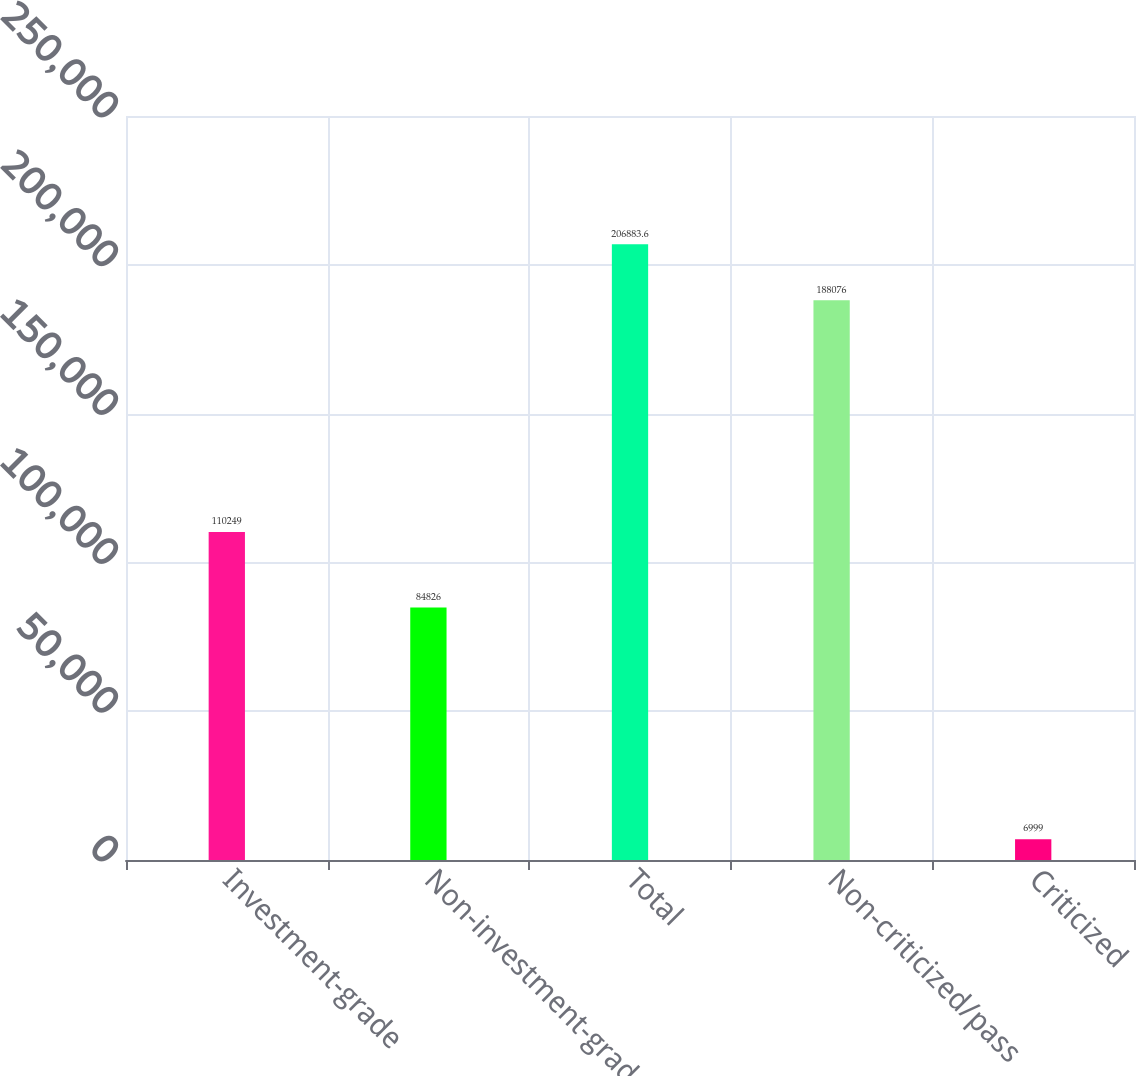Convert chart. <chart><loc_0><loc_0><loc_500><loc_500><bar_chart><fcel>Investment-grade<fcel>Non-investment-grade<fcel>Total<fcel>Non-criticized/pass<fcel>Criticized<nl><fcel>110249<fcel>84826<fcel>206884<fcel>188076<fcel>6999<nl></chart> 